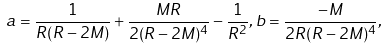<formula> <loc_0><loc_0><loc_500><loc_500>a = \frac { 1 } { R ( R - 2 M ) } + \frac { M R } { 2 ( R - 2 M ) ^ { 4 } } - \frac { 1 } { R ^ { 2 } } , b = \frac { - M } { 2 R ( R - 2 M ) ^ { 4 } } ,</formula> 